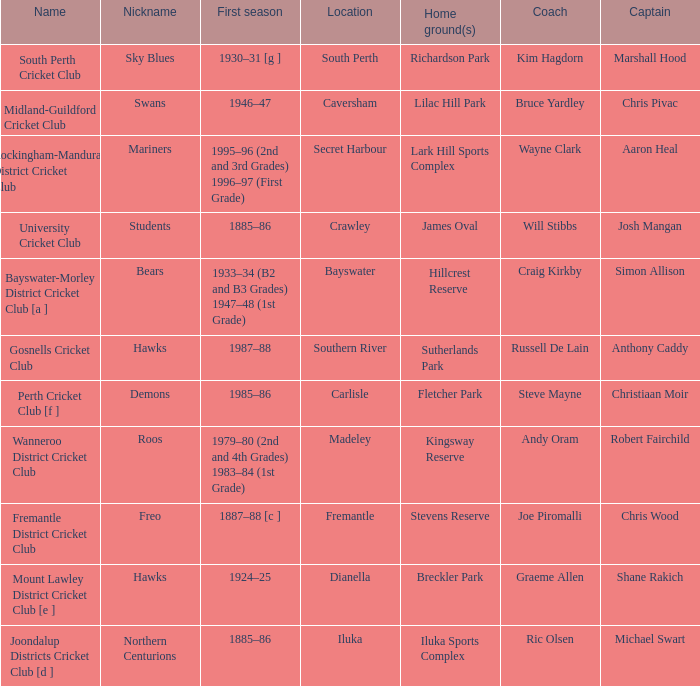What is the code nickname where Steve Mayne is the coach? Demons. 